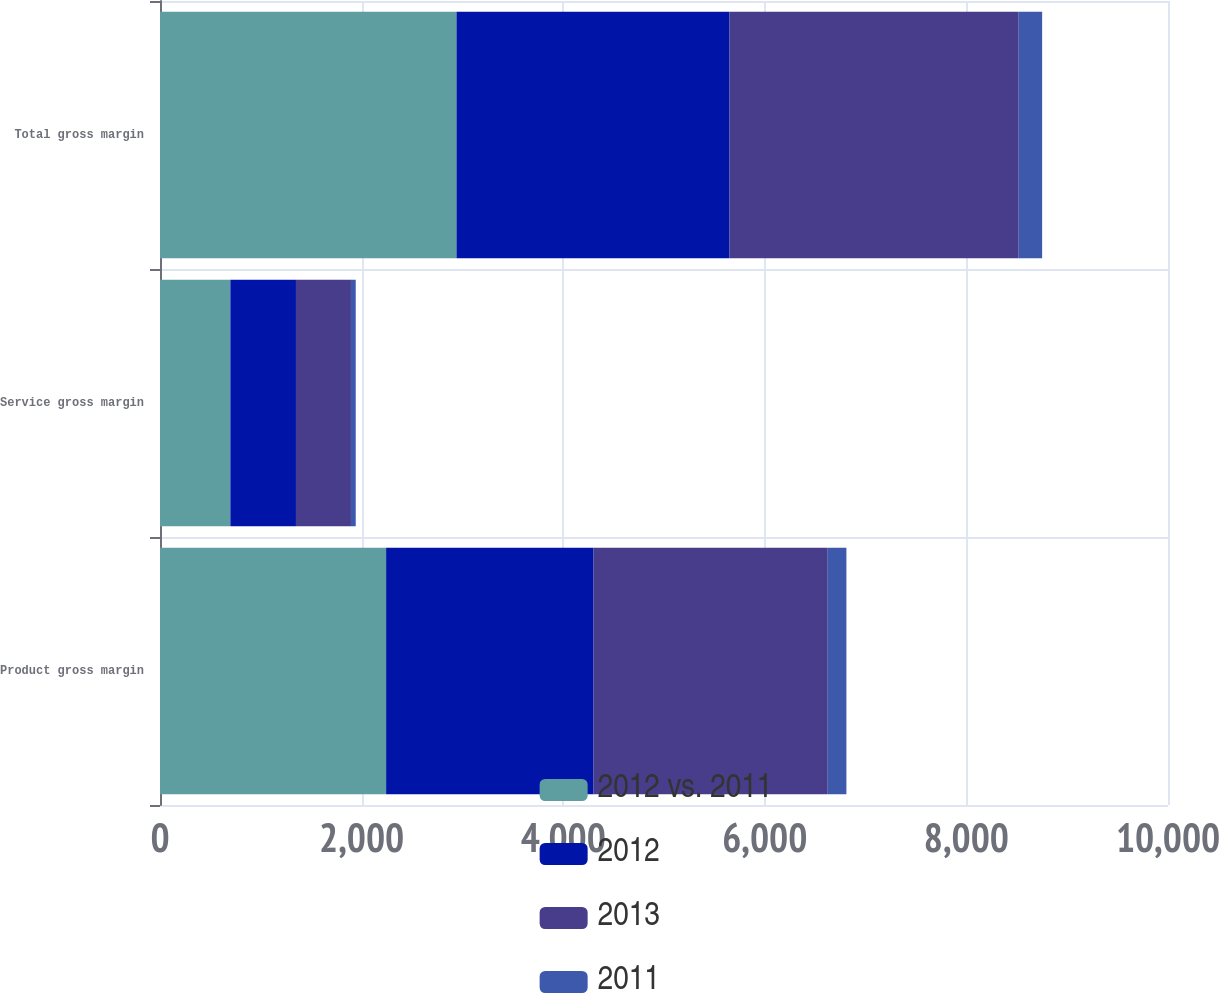Convert chart to OTSL. <chart><loc_0><loc_0><loc_500><loc_500><stacked_bar_chart><ecel><fcel>Product gross margin<fcel>Service gross margin<fcel>Total gross margin<nl><fcel>2012 vs. 2011<fcel>2243.3<fcel>698.1<fcel>2941.4<nl><fcel>2012<fcel>2058.1<fcel>650.7<fcel>2708.8<nl><fcel>2013<fcel>2323<fcel>545.6<fcel>2868.6<nl><fcel>2011<fcel>185.2<fcel>47.4<fcel>232.6<nl></chart> 